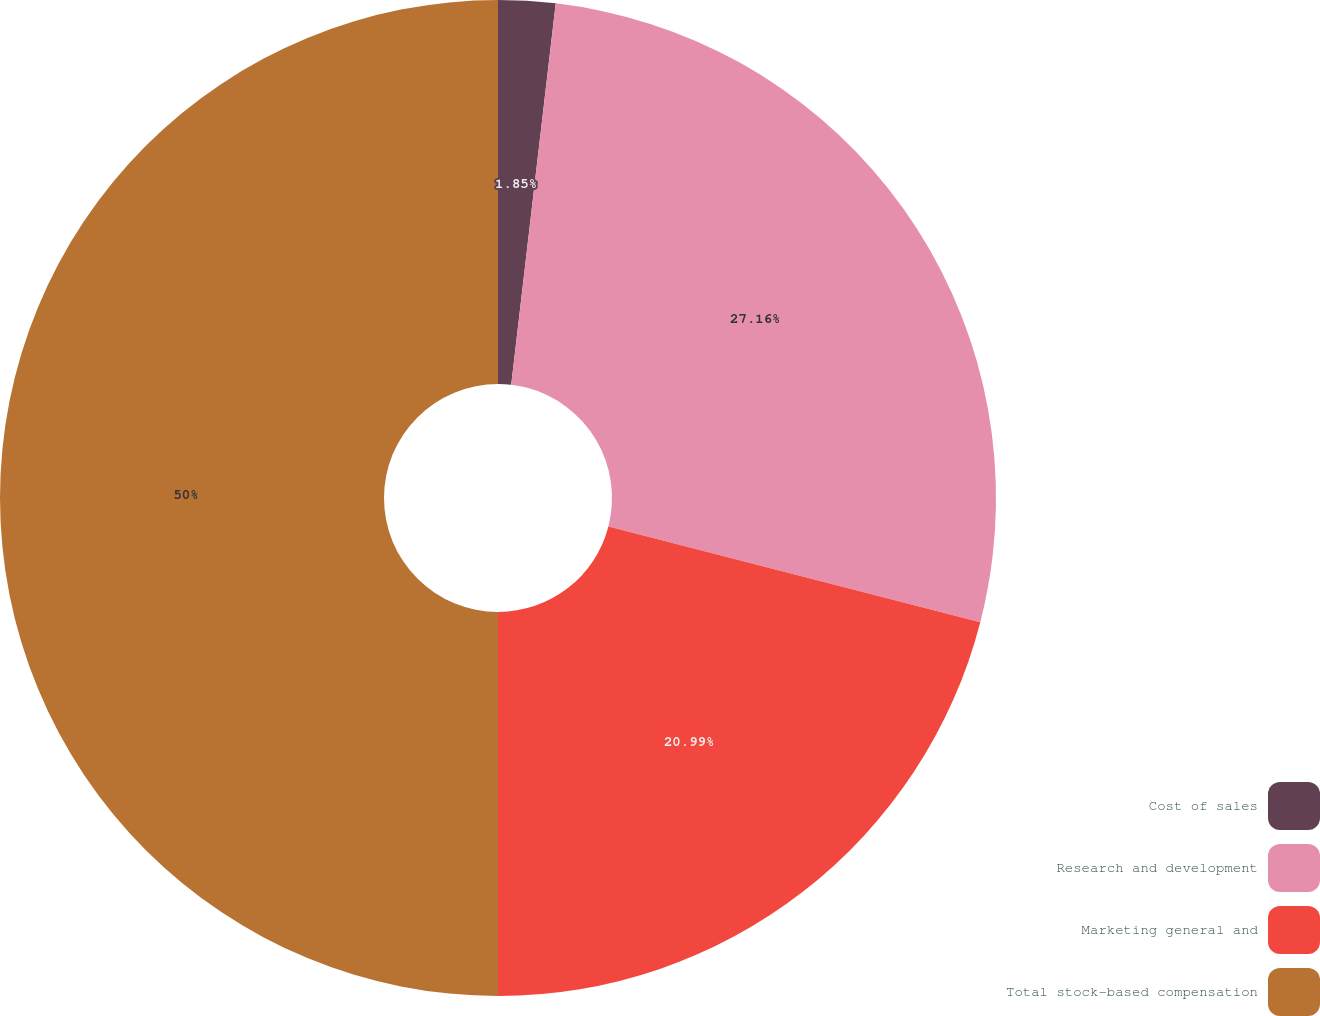Convert chart. <chart><loc_0><loc_0><loc_500><loc_500><pie_chart><fcel>Cost of sales<fcel>Research and development<fcel>Marketing general and<fcel>Total stock-based compensation<nl><fcel>1.85%<fcel>27.16%<fcel>20.99%<fcel>50.0%<nl></chart> 